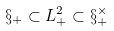<formula> <loc_0><loc_0><loc_500><loc_500>\S _ { + } \subset L ^ { 2 } _ { + } \subset \S _ { + } ^ { \times }</formula> 